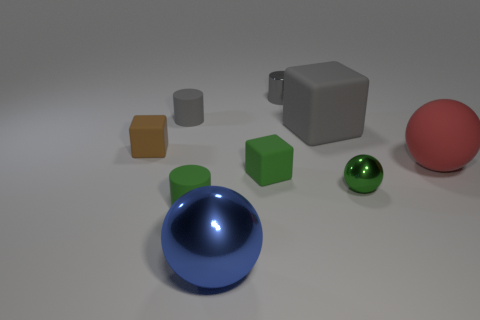There is a tiny shiny cylinder; how many green matte cubes are behind it?
Your answer should be very brief. 0. There is a small object that is to the right of the gray object behind the rubber cylinder behind the small green metal thing; what is its color?
Ensure brevity in your answer.  Green. There is a large rubber object that is left of the tiny green ball; is its color the same as the tiny cube behind the big red thing?
Your answer should be compact. No. The green matte thing that is in front of the tiny matte cube that is in front of the tiny brown cube is what shape?
Your answer should be compact. Cylinder. Is there a yellow metal cylinder that has the same size as the brown matte cube?
Keep it short and to the point. No. What number of other large red things are the same shape as the big metallic thing?
Give a very brief answer. 1. Are there the same number of green things that are in front of the large shiny ball and red balls that are in front of the red thing?
Make the answer very short. Yes. Are any big red objects visible?
Offer a terse response. Yes. What is the size of the matte cylinder behind the green matte object that is on the right side of the small green object left of the blue sphere?
Give a very brief answer. Small. There is a metal thing that is the same size as the green shiny ball; what shape is it?
Offer a terse response. Cylinder. 